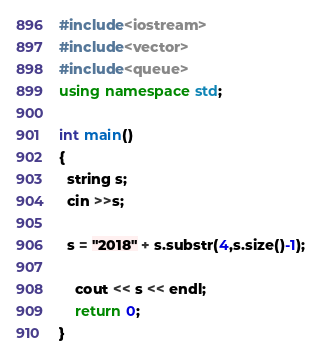Convert code to text. <code><loc_0><loc_0><loc_500><loc_500><_C++_>#include<iostream>
#include<vector>
#include<queue>
using namespace std;

int main()
{
  string s;
  cin >>s;
  
  s = "2018" + s.substr(4,s.size()-1);
  
    cout << s << endl;
    return 0;
}




</code> 